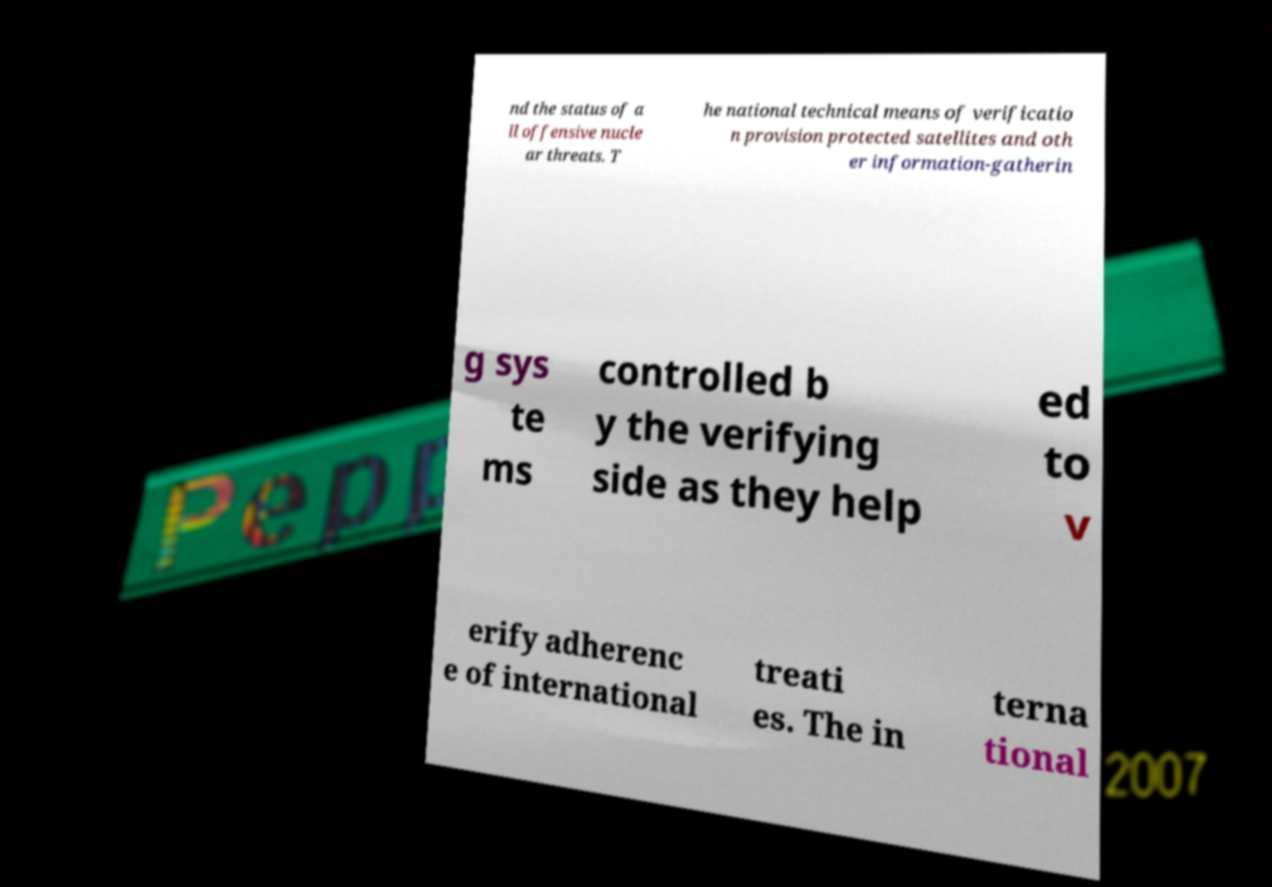For documentation purposes, I need the text within this image transcribed. Could you provide that? nd the status of a ll offensive nucle ar threats. T he national technical means of verificatio n provision protected satellites and oth er information-gatherin g sys te ms controlled b y the verifying side as they help ed to v erify adherenc e of international treati es. The in terna tional 